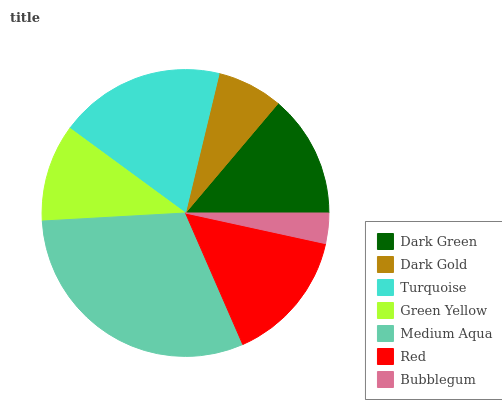Is Bubblegum the minimum?
Answer yes or no. Yes. Is Medium Aqua the maximum?
Answer yes or no. Yes. Is Dark Gold the minimum?
Answer yes or no. No. Is Dark Gold the maximum?
Answer yes or no. No. Is Dark Green greater than Dark Gold?
Answer yes or no. Yes. Is Dark Gold less than Dark Green?
Answer yes or no. Yes. Is Dark Gold greater than Dark Green?
Answer yes or no. No. Is Dark Green less than Dark Gold?
Answer yes or no. No. Is Dark Green the high median?
Answer yes or no. Yes. Is Dark Green the low median?
Answer yes or no. Yes. Is Green Yellow the high median?
Answer yes or no. No. Is Turquoise the low median?
Answer yes or no. No. 